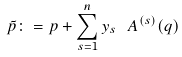<formula> <loc_0><loc_0><loc_500><loc_500>\tilde { p } \colon = p + \sum _ { s = 1 } ^ { n } y _ { s } \text { } A ^ { ( s ) } ( q )</formula> 